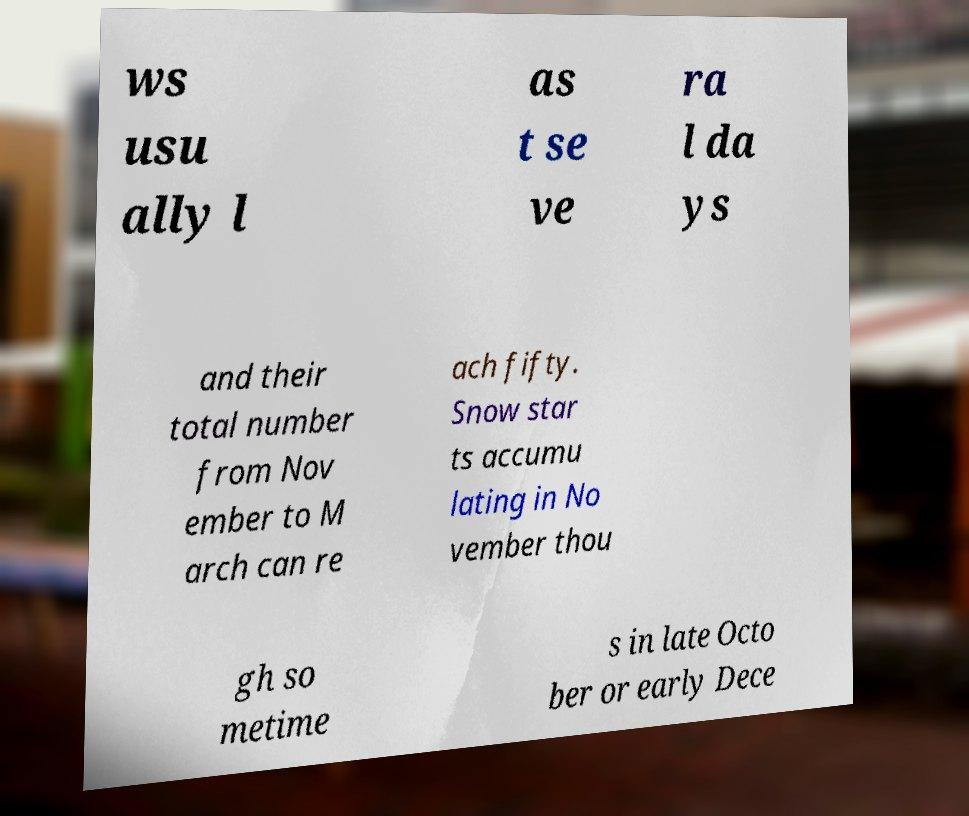Can you accurately transcribe the text from the provided image for me? ws usu ally l as t se ve ra l da ys and their total number from Nov ember to M arch can re ach fifty. Snow star ts accumu lating in No vember thou gh so metime s in late Octo ber or early Dece 